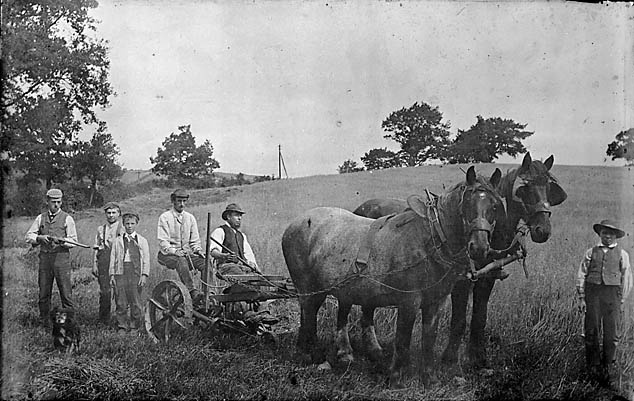Describe the objects in this image and their specific colors. I can see horse in black, gray, darkgray, and lightgray tones, horse in black, gray, and lightgray tones, people in black, gray, darkgray, and lightgray tones, people in black, gray, darkgray, and lightgray tones, and people in black, gray, darkgray, and lightgray tones in this image. 